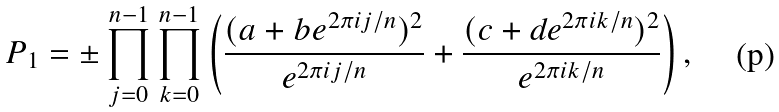Convert formula to latex. <formula><loc_0><loc_0><loc_500><loc_500>P _ { 1 } = \pm \prod _ { j = 0 } ^ { n - 1 } \prod _ { k = 0 } ^ { n - 1 } \left ( \frac { ( a + b e ^ { 2 \pi i j / n } ) ^ { 2 } } { e ^ { 2 \pi i j / n } } + \frac { ( c + d e ^ { 2 \pi i k / n } ) ^ { 2 } } { e ^ { 2 \pi i k / n } } \right ) ,</formula> 